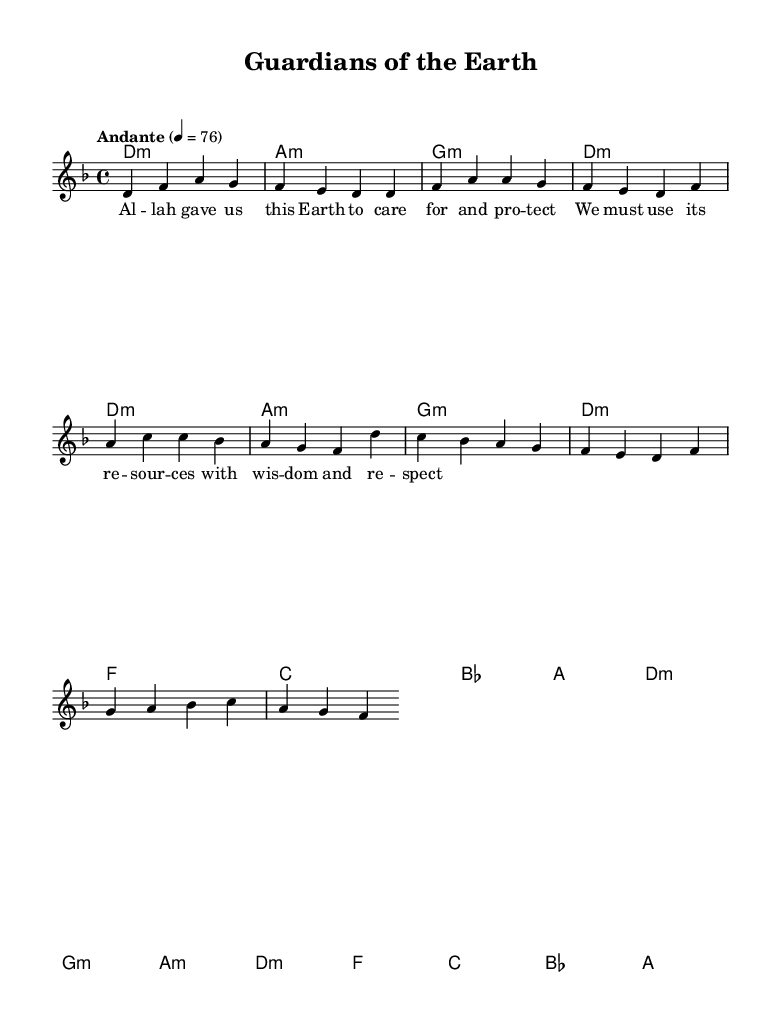What is the key signature of this music? The key signature is D minor, which is indicated by one flat (B flat) on the staff.
Answer: D minor What is the time signature of this music? The time signature is indicated at the beginning of the staff, and it is 4/4, meaning there are four beats in a measure.
Answer: 4/4 What is the tempo marking of this piece? The tempo marking is indicated at the beginning as "Andante," which suggests a moderate walking pace.
Answer: Andante How many measures are in the verse section? The verse section consists of two repeated musical phrases, each of which can be counted as four measures, totaling eight measures.
Answer: 8 measures What type of music is this? This piece is categorized as a nasheed, which is a form of Islamic devotional music focusing on themes of spirituality and environmental care.
Answer: Nasheed What is the primary message conveyed in the lyrics? The lyrics of this nasheed emphasize the importance of caring for the Earth and using its resources responsibly, suggesting a connection between spirituality and environmental stewardship.
Answer: Caring for the Earth Which chords are used in the chorus? The chords in the chorus are D minor, G minor, A minor, and F major, among others, indicating a progression typical in religious compositions.
Answer: D minor, G minor, A minor, F major 